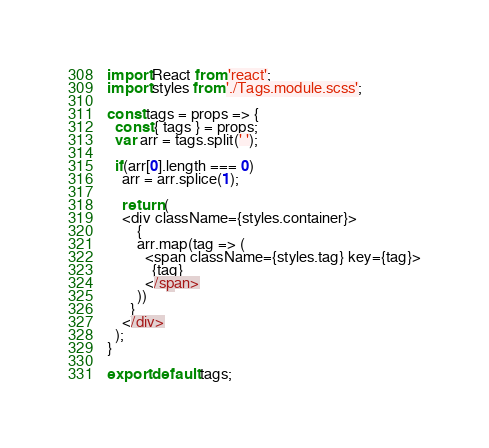<code> <loc_0><loc_0><loc_500><loc_500><_JavaScript_>import React from 'react';
import styles from './Tags.module.scss';

const tags = props => {
  const { tags } = props;
  var arr = tags.split(' ');

  if(arr[0].length === 0)
    arr = arr.splice(1);

    return (
    <div className={styles.container}>
        {
        arr.map(tag => (
          <span className={styles.tag} key={tag}>
            {tag}
          </span>
        ))
      }
    </div>
  );
}

export default tags;</code> 